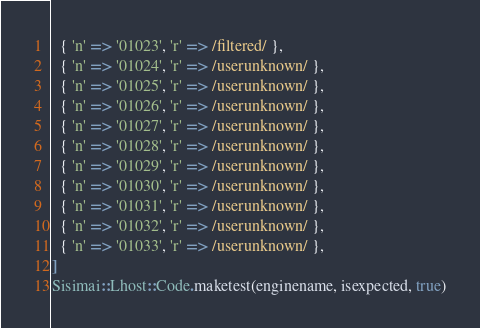<code> <loc_0><loc_0><loc_500><loc_500><_Ruby_>  { 'n' => '01023', 'r' => /filtered/ },
  { 'n' => '01024', 'r' => /userunknown/ },
  { 'n' => '01025', 'r' => /userunknown/ },
  { 'n' => '01026', 'r' => /userunknown/ },
  { 'n' => '01027', 'r' => /userunknown/ },
  { 'n' => '01028', 'r' => /userunknown/ },
  { 'n' => '01029', 'r' => /userunknown/ },
  { 'n' => '01030', 'r' => /userunknown/ },
  { 'n' => '01031', 'r' => /userunknown/ },
  { 'n' => '01032', 'r' => /userunknown/ },
  { 'n' => '01033', 'r' => /userunknown/ },
]
Sisimai::Lhost::Code.maketest(enginename, isexpected, true)

</code> 